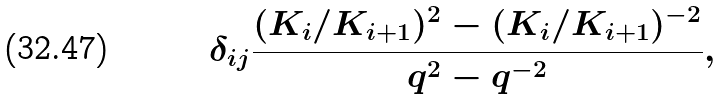Convert formula to latex. <formula><loc_0><loc_0><loc_500><loc_500>\delta _ { i j } \frac { ( K _ { i } / K _ { i + 1 } ) ^ { 2 } - ( K _ { i } / K _ { i + 1 } ) ^ { - 2 } } { q ^ { 2 } - q ^ { - 2 } } ,</formula> 